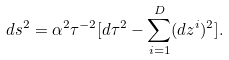<formula> <loc_0><loc_0><loc_500><loc_500>d s ^ { 2 } = \alpha ^ { 2 } \tau ^ { - 2 } [ d \tau ^ { 2 } - \sum _ { i = 1 } ^ { D } ( d z ^ { i } ) ^ { 2 } ] .</formula> 